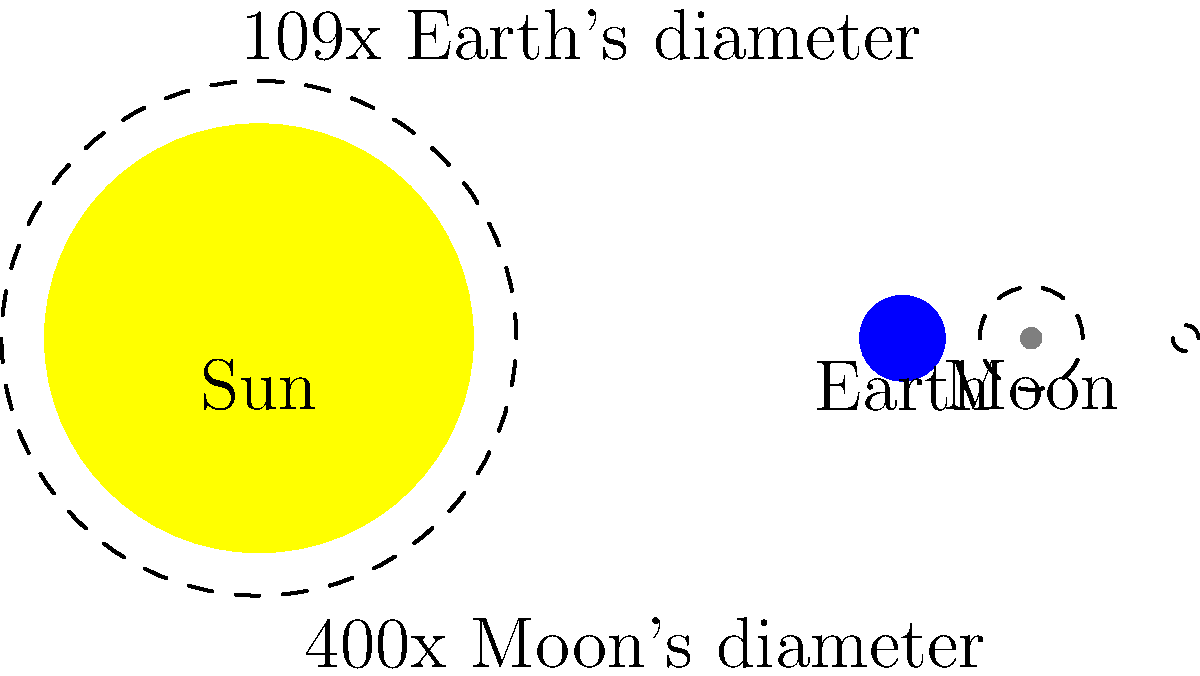Given the relative sizes of the Sun, Earth, and Moon as shown in the diagram, how many times larger is the surface area of the Sun compared to the Earth? Consider how this vast difference in size could impact the potential for solar energy collection in space versus on Earth. To solve this problem, let's follow these steps:

1. Recall the formula for the surface area of a sphere: $A = 4\pi r^2$

2. From the diagram, we can see that the Sun's diameter is 109 times that of Earth. This means the Sun's radius is also 109 times Earth's radius.

3. Let's denote Earth's radius as $r_E$ and Sun's radius as $r_S$. We can write:
   $r_S = 109r_E$

4. Now, let's calculate the ratio of surface areas:
   
   $\frac{A_S}{A_E} = \frac{4\pi r_S^2}{4\pi r_E^2}$

5. The $4\pi$ cancels out:

   $\frac{A_S}{A_E} = \frac{r_S^2}{r_E^2}$

6. Substitute $r_S = 109r_E$:

   $\frac{A_S}{A_E} = \frac{(109r_E)^2}{r_E^2} = \frac{11881r_E^2}{r_E^2} = 11881$

7. Therefore, the Sun's surface area is 11,881 times larger than Earth's.

This vast difference in surface area illustrates the enormous potential for solar energy collection in space compared to Earth. A space-based solar farm near the Sun could theoretically collect thousands of times more energy than one of equal size on Earth, not considering factors like atmospheric interference or day-night cycles.
Answer: 11,881 times larger 